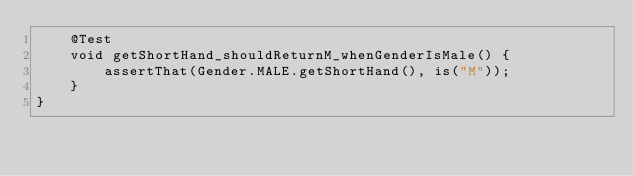<code> <loc_0><loc_0><loc_500><loc_500><_Java_>    @Test
    void getShortHand_shouldReturnM_whenGenderIsMale() {
        assertThat(Gender.MALE.getShortHand(), is("M"));
    }
}
</code> 